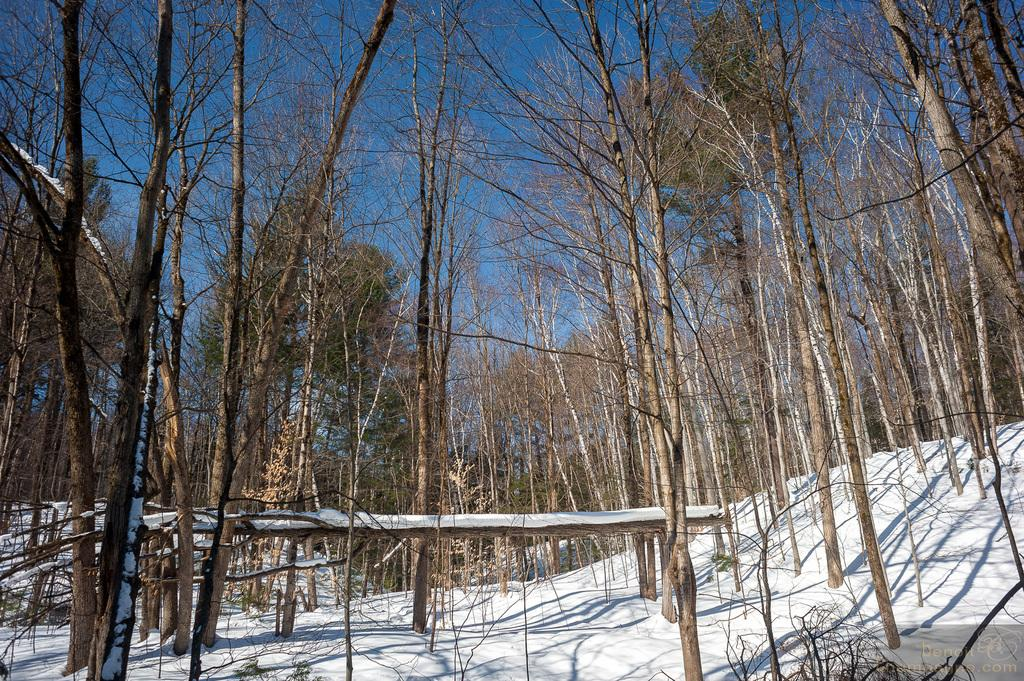What is visible in the background of the image? The sky is visible in the image. What type of vegetation can be seen in the image? There are trees in the image. What is the weather like in the image? The presence of snow in the image suggests that it is a snowy scene. How many pigs can be seen playing on the edge of the image? There are no pigs present in the image. What type of bit is being used by the person in the image? There is no person or bit present in the image. 